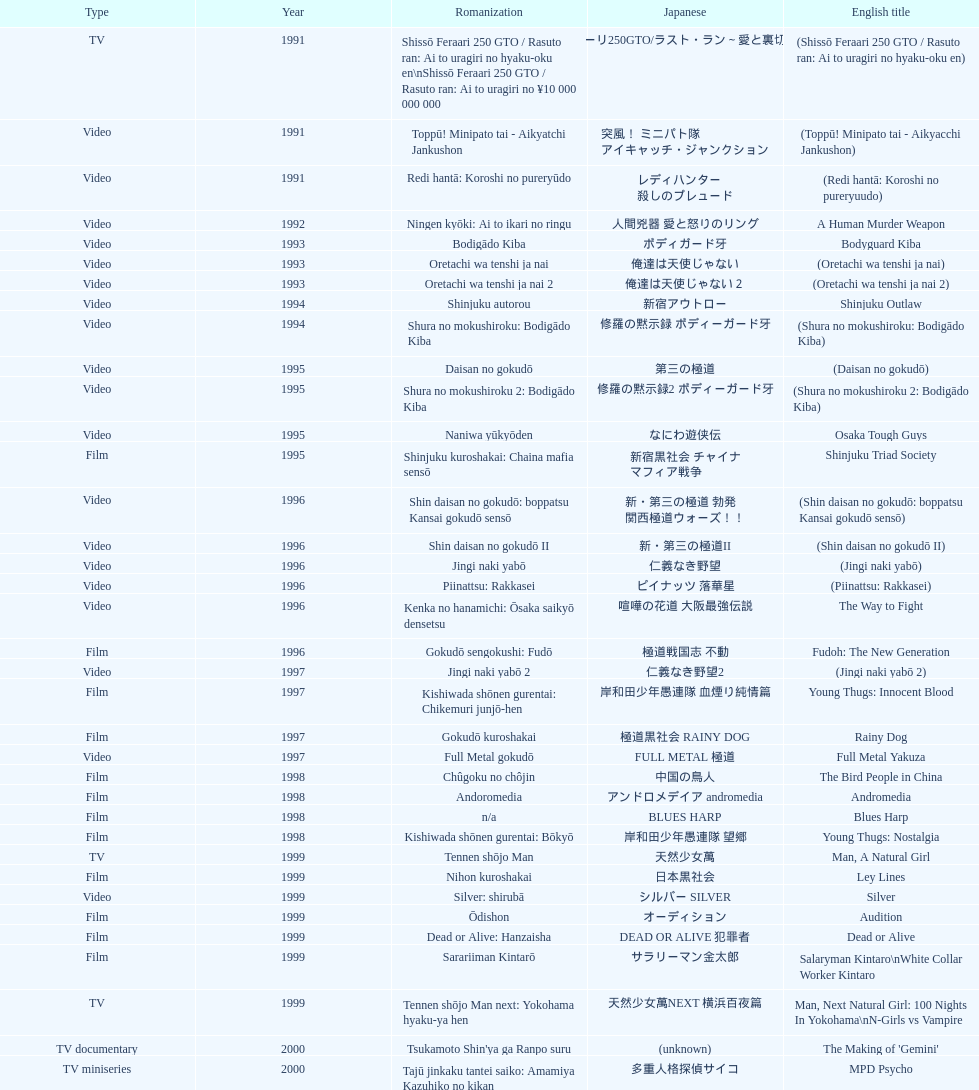Which title is listed next after "the way to fight"? Fudoh: The New Generation. 